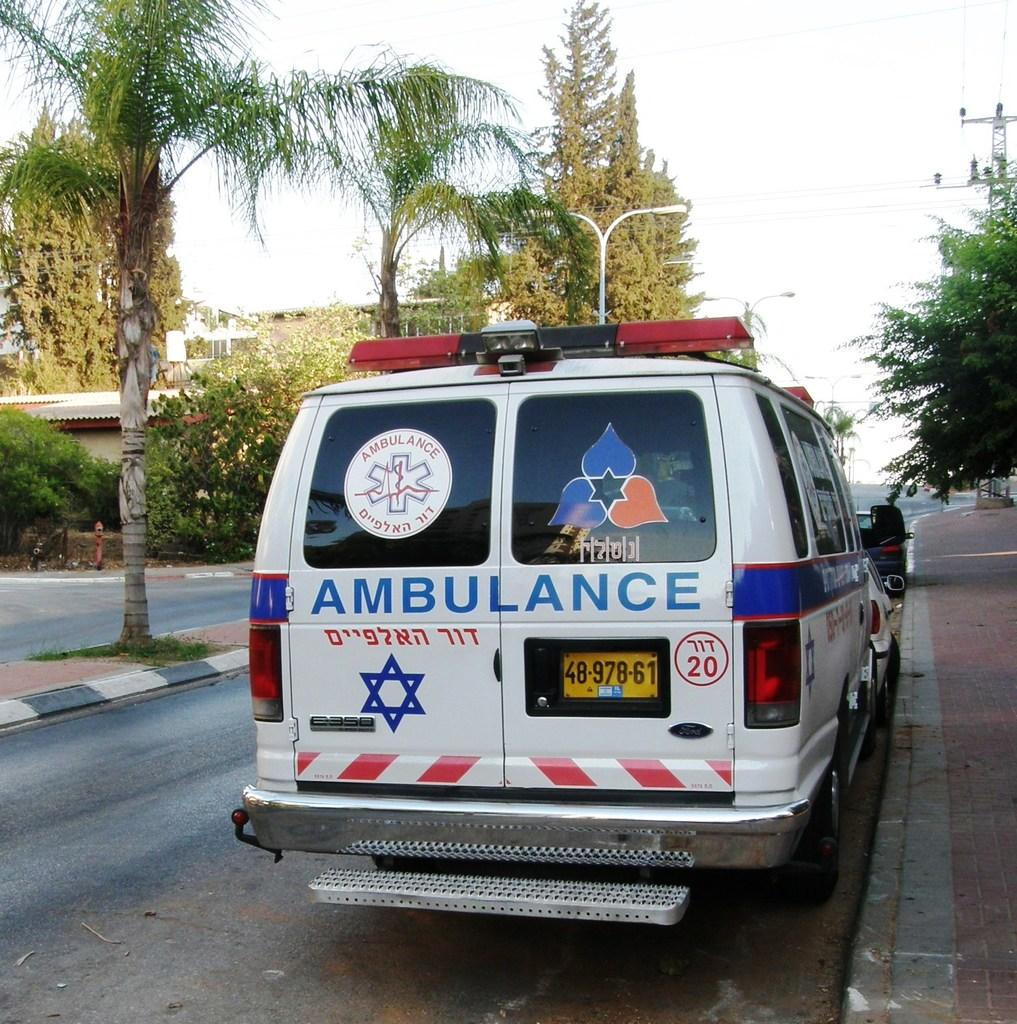<image>
Create a compact narrative representing the image presented. An ambulance has a yellow license plate that reads 4897861. 